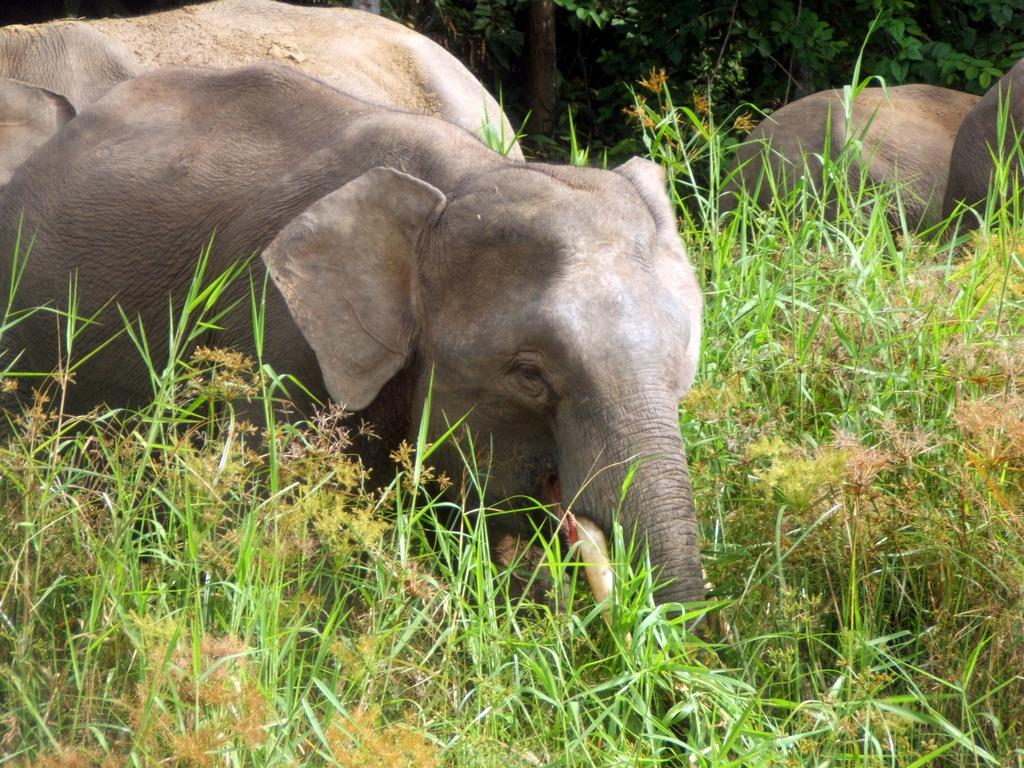How many elephants are present in the image? There are three elephants in the image. What are the elephants doing in the image? The elephants are standing in the image. What type of vegetation can be seen in the image? There are many plants and a tree in the image. What color is the afterthought in the image? There is no afterthought present in the image. How many circles can be seen in the image? There are no circles visible in the image. 